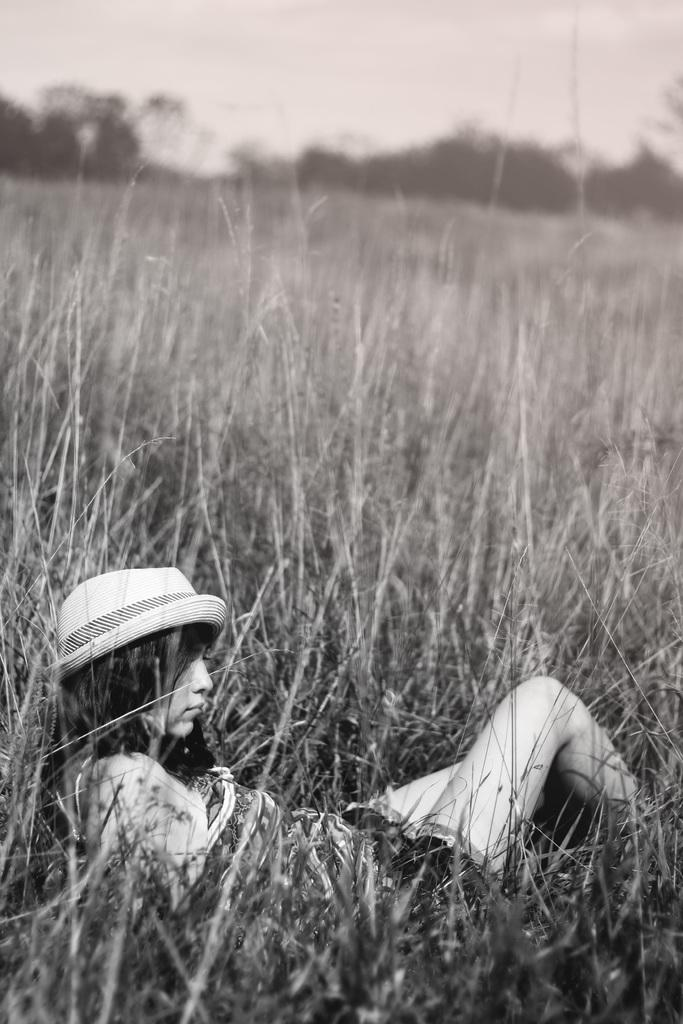What is the color scheme of the image? The image is black and white. Who is present in the image? There is a woman in the image. What is the woman doing in the image? The woman is lying on plants. What is the woman wearing in the image? The woman is wearing a hat. What can be seen at the top of the image? Trees and the sky are visible at the top of the image. What type of fang can be seen in the woman's hand in the image? There is no fang present in the image; the woman is lying on plants and wearing a hat. How are the ants using the woman's hat in the image? There are no ants present in the image, and the woman is wearing a hat. 